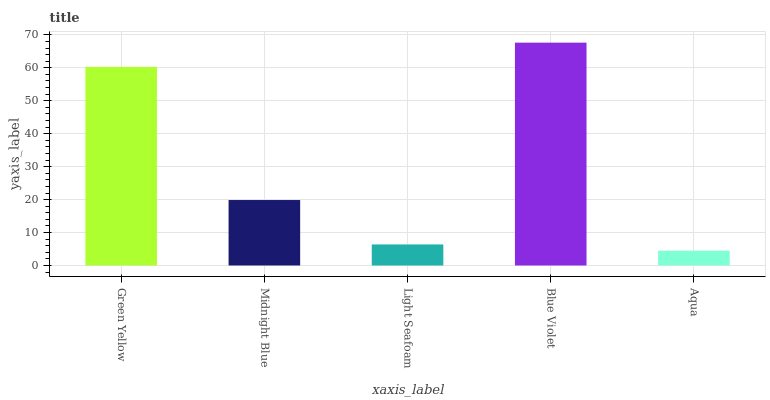Is Aqua the minimum?
Answer yes or no. Yes. Is Blue Violet the maximum?
Answer yes or no. Yes. Is Midnight Blue the minimum?
Answer yes or no. No. Is Midnight Blue the maximum?
Answer yes or no. No. Is Green Yellow greater than Midnight Blue?
Answer yes or no. Yes. Is Midnight Blue less than Green Yellow?
Answer yes or no. Yes. Is Midnight Blue greater than Green Yellow?
Answer yes or no. No. Is Green Yellow less than Midnight Blue?
Answer yes or no. No. Is Midnight Blue the high median?
Answer yes or no. Yes. Is Midnight Blue the low median?
Answer yes or no. Yes. Is Light Seafoam the high median?
Answer yes or no. No. Is Green Yellow the low median?
Answer yes or no. No. 